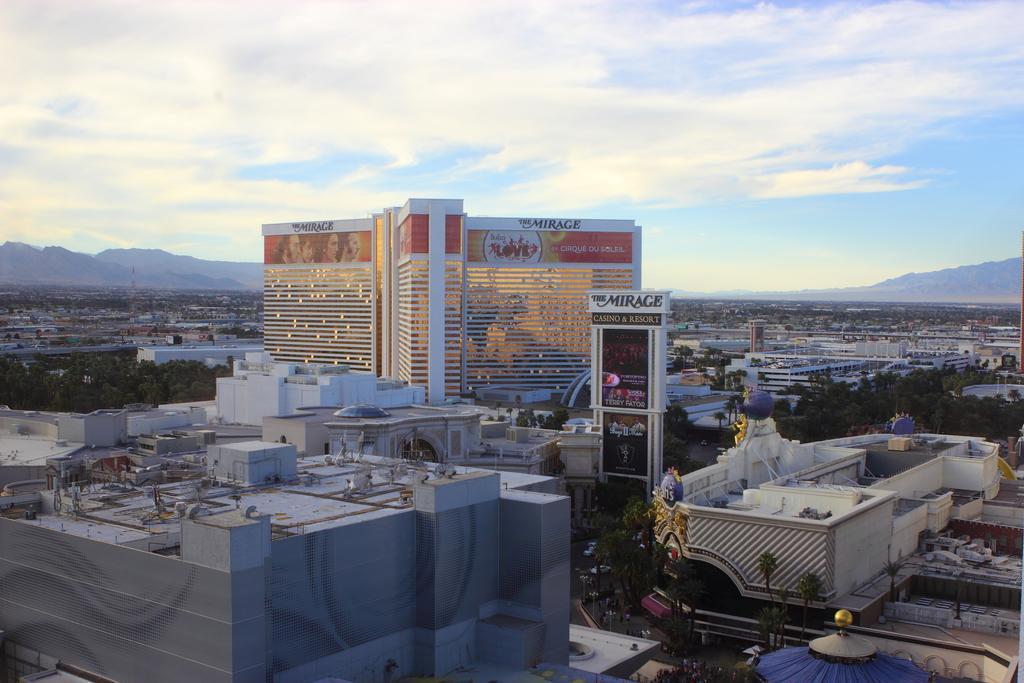How would you summarize this image in a sentence or two? In this image, I can see the view of the city. These are the buildings. This looks like a board. I can see the trees. In the background, these look like the hills. I think this is a road. These are the clouds in the sky. 